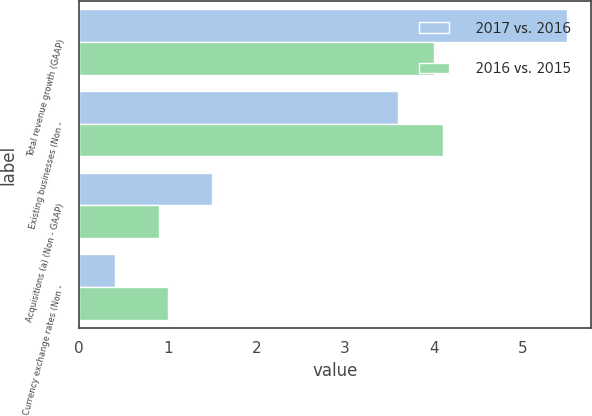Convert chart. <chart><loc_0><loc_0><loc_500><loc_500><stacked_bar_chart><ecel><fcel>Total revenue growth (GAAP)<fcel>Existing businesses (Non -<fcel>Acquisitions (a) (Non - GAAP)<fcel>Currency exchange rates (Non -<nl><fcel>2017 vs. 2016<fcel>5.5<fcel>3.6<fcel>1.5<fcel>0.4<nl><fcel>2016 vs. 2015<fcel>4<fcel>4.1<fcel>0.9<fcel>1<nl></chart> 